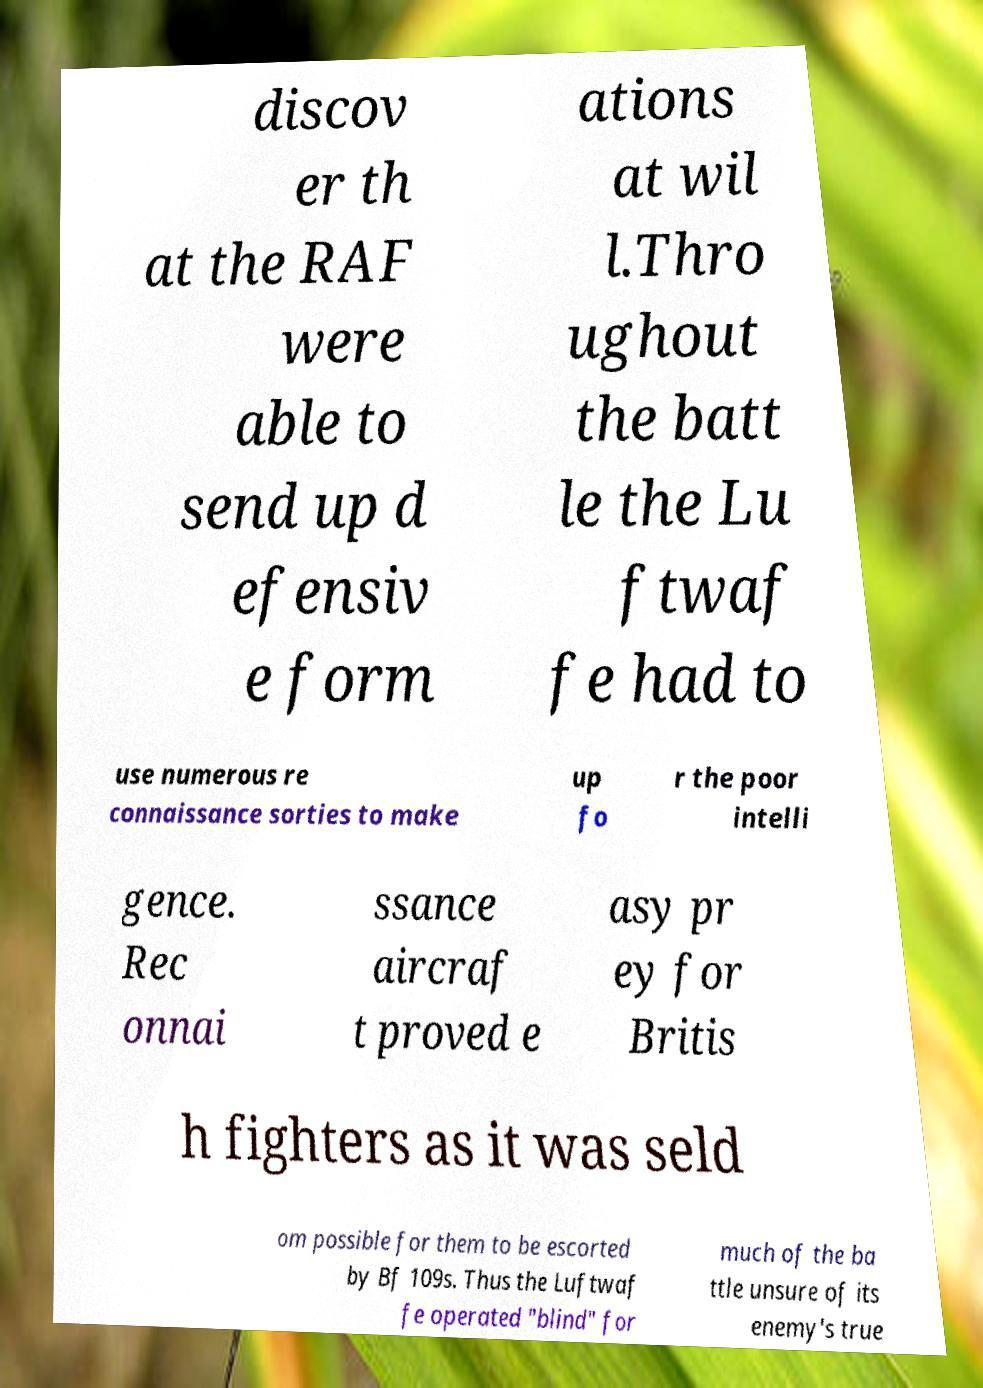Please identify and transcribe the text found in this image. discov er th at the RAF were able to send up d efensiv e form ations at wil l.Thro ughout the batt le the Lu ftwaf fe had to use numerous re connaissance sorties to make up fo r the poor intelli gence. Rec onnai ssance aircraf t proved e asy pr ey for Britis h fighters as it was seld om possible for them to be escorted by Bf 109s. Thus the Luftwaf fe operated "blind" for much of the ba ttle unsure of its enemy's true 